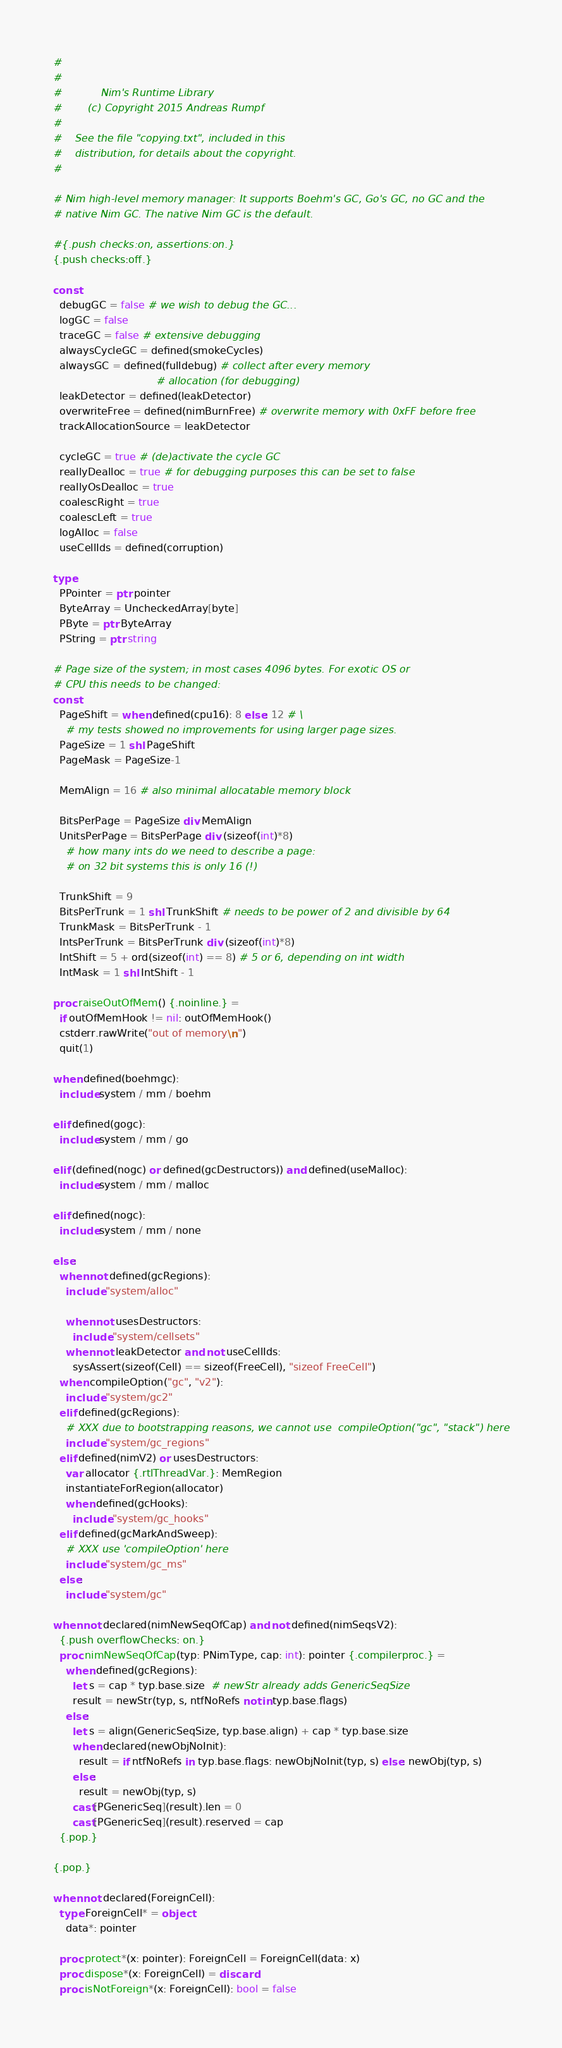Convert code to text. <code><loc_0><loc_0><loc_500><loc_500><_Nim_>#
#
#            Nim's Runtime Library
#        (c) Copyright 2015 Andreas Rumpf
#
#    See the file "copying.txt", included in this
#    distribution, for details about the copyright.
#

# Nim high-level memory manager: It supports Boehm's GC, Go's GC, no GC and the
# native Nim GC. The native Nim GC is the default.

#{.push checks:on, assertions:on.}
{.push checks:off.}

const
  debugGC = false # we wish to debug the GC...
  logGC = false
  traceGC = false # extensive debugging
  alwaysCycleGC = defined(smokeCycles)
  alwaysGC = defined(fulldebug) # collect after every memory
                                # allocation (for debugging)
  leakDetector = defined(leakDetector)
  overwriteFree = defined(nimBurnFree) # overwrite memory with 0xFF before free
  trackAllocationSource = leakDetector

  cycleGC = true # (de)activate the cycle GC
  reallyDealloc = true # for debugging purposes this can be set to false
  reallyOsDealloc = true
  coalescRight = true
  coalescLeft = true
  logAlloc = false
  useCellIds = defined(corruption)

type
  PPointer = ptr pointer
  ByteArray = UncheckedArray[byte]
  PByte = ptr ByteArray
  PString = ptr string

# Page size of the system; in most cases 4096 bytes. For exotic OS or
# CPU this needs to be changed:
const
  PageShift = when defined(cpu16): 8 else: 12 # \
    # my tests showed no improvements for using larger page sizes.
  PageSize = 1 shl PageShift
  PageMask = PageSize-1

  MemAlign = 16 # also minimal allocatable memory block

  BitsPerPage = PageSize div MemAlign
  UnitsPerPage = BitsPerPage div (sizeof(int)*8)
    # how many ints do we need to describe a page:
    # on 32 bit systems this is only 16 (!)

  TrunkShift = 9
  BitsPerTrunk = 1 shl TrunkShift # needs to be power of 2 and divisible by 64
  TrunkMask = BitsPerTrunk - 1
  IntsPerTrunk = BitsPerTrunk div (sizeof(int)*8)
  IntShift = 5 + ord(sizeof(int) == 8) # 5 or 6, depending on int width
  IntMask = 1 shl IntShift - 1

proc raiseOutOfMem() {.noinline.} =
  if outOfMemHook != nil: outOfMemHook()
  cstderr.rawWrite("out of memory\n")
  quit(1)

when defined(boehmgc):
  include system / mm / boehm

elif defined(gogc):
  include system / mm / go

elif (defined(nogc) or defined(gcDestructors)) and defined(useMalloc):
  include system / mm / malloc

elif defined(nogc):
  include system / mm / none

else:
  when not defined(gcRegions):
    include "system/alloc"

    when not usesDestructors:
      include "system/cellsets"
    when not leakDetector and not useCellIds:
      sysAssert(sizeof(Cell) == sizeof(FreeCell), "sizeof FreeCell")
  when compileOption("gc", "v2"):
    include "system/gc2"
  elif defined(gcRegions):
    # XXX due to bootstrapping reasons, we cannot use  compileOption("gc", "stack") here
    include "system/gc_regions"
  elif defined(nimV2) or usesDestructors:
    var allocator {.rtlThreadVar.}: MemRegion
    instantiateForRegion(allocator)
    when defined(gcHooks):
      include "system/gc_hooks"
  elif defined(gcMarkAndSweep):
    # XXX use 'compileOption' here
    include "system/gc_ms"
  else:
    include "system/gc"

when not declared(nimNewSeqOfCap) and not defined(nimSeqsV2):
  {.push overflowChecks: on.}
  proc nimNewSeqOfCap(typ: PNimType, cap: int): pointer {.compilerproc.} =
    when defined(gcRegions):
      let s = cap * typ.base.size  # newStr already adds GenericSeqSize
      result = newStr(typ, s, ntfNoRefs notin typ.base.flags)
    else:
      let s = align(GenericSeqSize, typ.base.align) + cap * typ.base.size
      when declared(newObjNoInit):
        result = if ntfNoRefs in typ.base.flags: newObjNoInit(typ, s) else: newObj(typ, s)
      else:
        result = newObj(typ, s)
      cast[PGenericSeq](result).len = 0
      cast[PGenericSeq](result).reserved = cap
  {.pop.}

{.pop.}

when not declared(ForeignCell):
  type ForeignCell* = object
    data*: pointer

  proc protect*(x: pointer): ForeignCell = ForeignCell(data: x)
  proc dispose*(x: ForeignCell) = discard
  proc isNotForeign*(x: ForeignCell): bool = false
</code> 